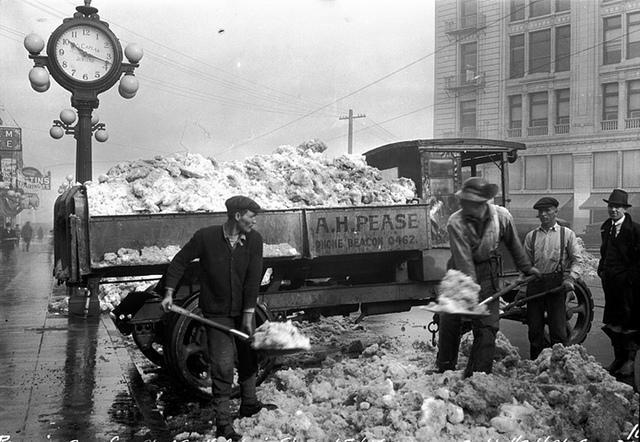How many people are there?
Give a very brief answer. 4. 